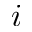<formula> <loc_0><loc_0><loc_500><loc_500>i</formula> 